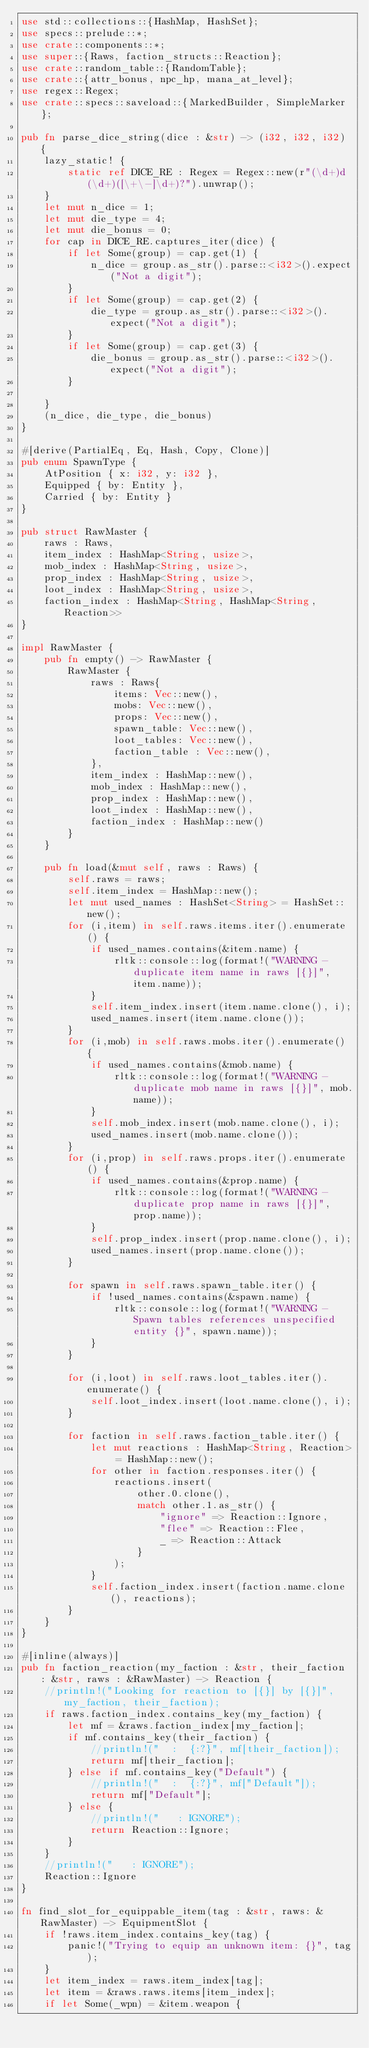Convert code to text. <code><loc_0><loc_0><loc_500><loc_500><_Rust_>use std::collections::{HashMap, HashSet};
use specs::prelude::*;
use crate::components::*;
use super::{Raws, faction_structs::Reaction};
use crate::random_table::{RandomTable};
use crate::{attr_bonus, npc_hp, mana_at_level};
use regex::Regex;
use crate::specs::saveload::{MarkedBuilder, SimpleMarker};

pub fn parse_dice_string(dice : &str) -> (i32, i32, i32) {
    lazy_static! {
        static ref DICE_RE : Regex = Regex::new(r"(\d+)d(\d+)([\+\-]\d+)?").unwrap();
    }
    let mut n_dice = 1;
    let mut die_type = 4;
    let mut die_bonus = 0;
    for cap in DICE_RE.captures_iter(dice) {
        if let Some(group) = cap.get(1) {
            n_dice = group.as_str().parse::<i32>().expect("Not a digit");
        }
        if let Some(group) = cap.get(2) {
            die_type = group.as_str().parse::<i32>().expect("Not a digit");
        }
        if let Some(group) = cap.get(3) {
            die_bonus = group.as_str().parse::<i32>().expect("Not a digit");
        }

    }
    (n_dice, die_type, die_bonus)
}

#[derive(PartialEq, Eq, Hash, Copy, Clone)]
pub enum SpawnType {
    AtPosition { x: i32, y: i32 },
    Equipped { by: Entity },
    Carried { by: Entity }
}

pub struct RawMaster {
    raws : Raws,
    item_index : HashMap<String, usize>,
    mob_index : HashMap<String, usize>,
    prop_index : HashMap<String, usize>,
    loot_index : HashMap<String, usize>,
    faction_index : HashMap<String, HashMap<String, Reaction>>
}

impl RawMaster {
    pub fn empty() -> RawMaster {
        RawMaster {
            raws : Raws{
                items: Vec::new(),
                mobs: Vec::new(),
                props: Vec::new(),
                spawn_table: Vec::new(),
                loot_tables: Vec::new(),
                faction_table : Vec::new(),
            },
            item_index : HashMap::new(),
            mob_index : HashMap::new(),
            prop_index : HashMap::new(),
            loot_index : HashMap::new(),
            faction_index : HashMap::new()
        }
    }

    pub fn load(&mut self, raws : Raws) {
        self.raws = raws;
        self.item_index = HashMap::new();
        let mut used_names : HashSet<String> = HashSet::new();
        for (i,item) in self.raws.items.iter().enumerate() {
            if used_names.contains(&item.name) {
                rltk::console::log(format!("WARNING -  duplicate item name in raws [{}]", item.name));
            }
            self.item_index.insert(item.name.clone(), i);
            used_names.insert(item.name.clone());
        }
        for (i,mob) in self.raws.mobs.iter().enumerate() {
            if used_names.contains(&mob.name) {
                rltk::console::log(format!("WARNING -  duplicate mob name in raws [{}]", mob.name));
            }
            self.mob_index.insert(mob.name.clone(), i);
            used_names.insert(mob.name.clone());
        }
        for (i,prop) in self.raws.props.iter().enumerate() {
            if used_names.contains(&prop.name) {
                rltk::console::log(format!("WARNING -  duplicate prop name in raws [{}]", prop.name));
            }
            self.prop_index.insert(prop.name.clone(), i);
            used_names.insert(prop.name.clone());
        }

        for spawn in self.raws.spawn_table.iter() {
            if !used_names.contains(&spawn.name) {
                rltk::console::log(format!("WARNING - Spawn tables references unspecified entity {}", spawn.name));
            }
        }

        for (i,loot) in self.raws.loot_tables.iter().enumerate() {
            self.loot_index.insert(loot.name.clone(), i);
        }

        for faction in self.raws.faction_table.iter() {
            let mut reactions : HashMap<String, Reaction> = HashMap::new();
            for other in faction.responses.iter() {
                reactions.insert(
                    other.0.clone(),
                    match other.1.as_str() {
                        "ignore" => Reaction::Ignore,
                        "flee" => Reaction::Flee,
                        _ => Reaction::Attack
                    }
                );
            }
            self.faction_index.insert(faction.name.clone(), reactions);
        }
    }
}

#[inline(always)]
pub fn faction_reaction(my_faction : &str, their_faction : &str, raws : &RawMaster) -> Reaction {
    //println!("Looking for reaction to [{}] by [{}]", my_faction, their_faction);
    if raws.faction_index.contains_key(my_faction) {
        let mf = &raws.faction_index[my_faction];
        if mf.contains_key(their_faction) {
            //println!("  :  {:?}", mf[their_faction]);
            return mf[their_faction];
        } else if mf.contains_key("Default") {
            //println!("  :  {:?}", mf["Default"]);
            return mf["Default"];
        } else {
            //println!("   : IGNORE");
            return Reaction::Ignore;
        }
    }
    //println!("   : IGNORE");
    Reaction::Ignore
}

fn find_slot_for_equippable_item(tag : &str, raws: &RawMaster) -> EquipmentSlot {
    if !raws.item_index.contains_key(tag) {
        panic!("Trying to equip an unknown item: {}", tag);
    }
    let item_index = raws.item_index[tag];
    let item = &raws.raws.items[item_index];
    if let Some(_wpn) = &item.weapon {</code> 